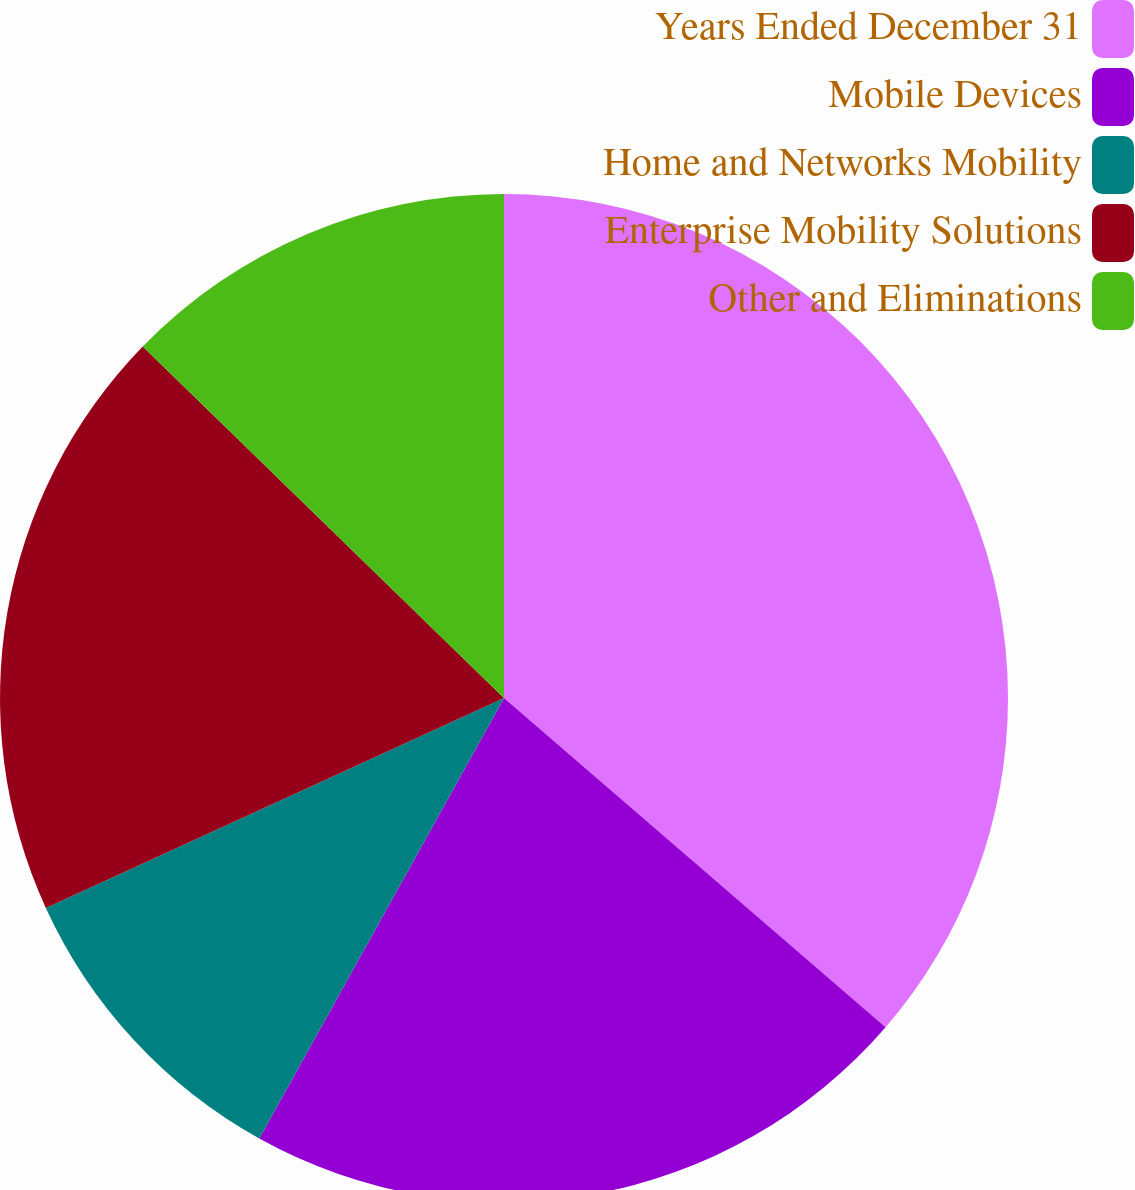Convert chart to OTSL. <chart><loc_0><loc_0><loc_500><loc_500><pie_chart><fcel>Years Ended December 31<fcel>Mobile Devices<fcel>Home and Networks Mobility<fcel>Enterprise Mobility Solutions<fcel>Other and Eliminations<nl><fcel>36.33%<fcel>21.74%<fcel>10.09%<fcel>19.12%<fcel>12.72%<nl></chart> 